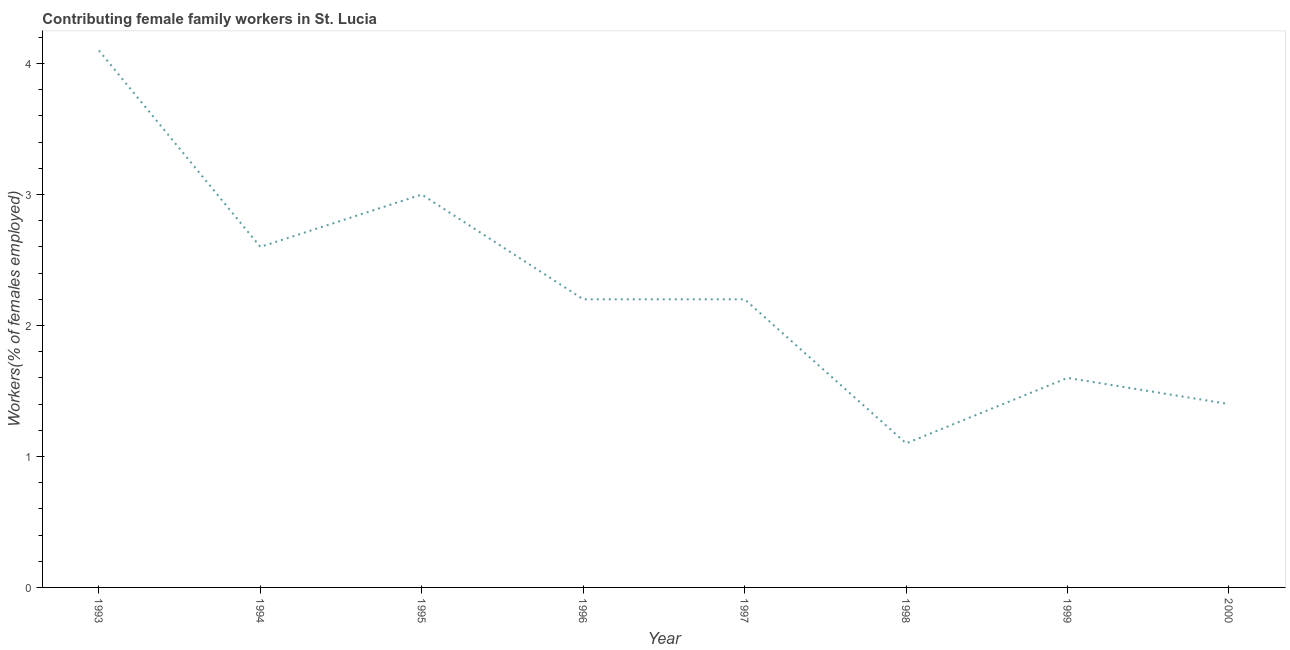Across all years, what is the maximum contributing female family workers?
Make the answer very short. 4.1. Across all years, what is the minimum contributing female family workers?
Your answer should be compact. 1.1. In which year was the contributing female family workers maximum?
Your answer should be very brief. 1993. In which year was the contributing female family workers minimum?
Provide a short and direct response. 1998. What is the sum of the contributing female family workers?
Offer a very short reply. 18.2. What is the difference between the contributing female family workers in 1998 and 2000?
Your answer should be compact. -0.3. What is the average contributing female family workers per year?
Your answer should be very brief. 2.27. What is the median contributing female family workers?
Your answer should be very brief. 2.2. Do a majority of the years between 1998 and 1993 (inclusive) have contributing female family workers greater than 0.2 %?
Ensure brevity in your answer.  Yes. What is the ratio of the contributing female family workers in 1993 to that in 2000?
Your answer should be compact. 2.93. What is the difference between the highest and the second highest contributing female family workers?
Offer a very short reply. 1.1. What is the difference between the highest and the lowest contributing female family workers?
Your answer should be very brief. 3. In how many years, is the contributing female family workers greater than the average contributing female family workers taken over all years?
Offer a very short reply. 3. Does the contributing female family workers monotonically increase over the years?
Ensure brevity in your answer.  No. How many lines are there?
Your answer should be compact. 1. What is the difference between two consecutive major ticks on the Y-axis?
Give a very brief answer. 1. Are the values on the major ticks of Y-axis written in scientific E-notation?
Your answer should be compact. No. Does the graph contain any zero values?
Offer a terse response. No. What is the title of the graph?
Ensure brevity in your answer.  Contributing female family workers in St. Lucia. What is the label or title of the X-axis?
Provide a succinct answer. Year. What is the label or title of the Y-axis?
Offer a terse response. Workers(% of females employed). What is the Workers(% of females employed) in 1993?
Make the answer very short. 4.1. What is the Workers(% of females employed) in 1994?
Offer a very short reply. 2.6. What is the Workers(% of females employed) in 1995?
Your response must be concise. 3. What is the Workers(% of females employed) of 1996?
Give a very brief answer. 2.2. What is the Workers(% of females employed) of 1997?
Offer a terse response. 2.2. What is the Workers(% of females employed) of 1998?
Your answer should be compact. 1.1. What is the Workers(% of females employed) in 1999?
Your answer should be very brief. 1.6. What is the Workers(% of females employed) of 2000?
Your response must be concise. 1.4. What is the difference between the Workers(% of females employed) in 1993 and 1994?
Your response must be concise. 1.5. What is the difference between the Workers(% of females employed) in 1993 and 1995?
Your response must be concise. 1.1. What is the difference between the Workers(% of females employed) in 1993 and 1999?
Provide a short and direct response. 2.5. What is the difference between the Workers(% of females employed) in 1993 and 2000?
Give a very brief answer. 2.7. What is the difference between the Workers(% of females employed) in 1994 and 1996?
Your answer should be compact. 0.4. What is the difference between the Workers(% of females employed) in 1994 and 1997?
Provide a short and direct response. 0.4. What is the difference between the Workers(% of females employed) in 1994 and 1998?
Provide a short and direct response. 1.5. What is the difference between the Workers(% of females employed) in 1994 and 2000?
Keep it short and to the point. 1.2. What is the difference between the Workers(% of females employed) in 1995 and 1996?
Ensure brevity in your answer.  0.8. What is the difference between the Workers(% of females employed) in 1995 and 1997?
Your response must be concise. 0.8. What is the difference between the Workers(% of females employed) in 1996 and 1998?
Offer a very short reply. 1.1. What is the difference between the Workers(% of females employed) in 1997 and 1998?
Your answer should be very brief. 1.1. What is the difference between the Workers(% of females employed) in 1997 and 1999?
Keep it short and to the point. 0.6. What is the difference between the Workers(% of females employed) in 1997 and 2000?
Give a very brief answer. 0.8. What is the difference between the Workers(% of females employed) in 1998 and 1999?
Your answer should be compact. -0.5. What is the ratio of the Workers(% of females employed) in 1993 to that in 1994?
Your answer should be compact. 1.58. What is the ratio of the Workers(% of females employed) in 1993 to that in 1995?
Your response must be concise. 1.37. What is the ratio of the Workers(% of females employed) in 1993 to that in 1996?
Your answer should be very brief. 1.86. What is the ratio of the Workers(% of females employed) in 1993 to that in 1997?
Give a very brief answer. 1.86. What is the ratio of the Workers(% of females employed) in 1993 to that in 1998?
Give a very brief answer. 3.73. What is the ratio of the Workers(% of females employed) in 1993 to that in 1999?
Give a very brief answer. 2.56. What is the ratio of the Workers(% of females employed) in 1993 to that in 2000?
Your response must be concise. 2.93. What is the ratio of the Workers(% of females employed) in 1994 to that in 1995?
Offer a very short reply. 0.87. What is the ratio of the Workers(% of females employed) in 1994 to that in 1996?
Offer a terse response. 1.18. What is the ratio of the Workers(% of females employed) in 1994 to that in 1997?
Make the answer very short. 1.18. What is the ratio of the Workers(% of females employed) in 1994 to that in 1998?
Ensure brevity in your answer.  2.36. What is the ratio of the Workers(% of females employed) in 1994 to that in 1999?
Provide a succinct answer. 1.62. What is the ratio of the Workers(% of females employed) in 1994 to that in 2000?
Your response must be concise. 1.86. What is the ratio of the Workers(% of females employed) in 1995 to that in 1996?
Your response must be concise. 1.36. What is the ratio of the Workers(% of females employed) in 1995 to that in 1997?
Keep it short and to the point. 1.36. What is the ratio of the Workers(% of females employed) in 1995 to that in 1998?
Give a very brief answer. 2.73. What is the ratio of the Workers(% of females employed) in 1995 to that in 1999?
Keep it short and to the point. 1.88. What is the ratio of the Workers(% of females employed) in 1995 to that in 2000?
Make the answer very short. 2.14. What is the ratio of the Workers(% of females employed) in 1996 to that in 1998?
Offer a very short reply. 2. What is the ratio of the Workers(% of females employed) in 1996 to that in 1999?
Provide a succinct answer. 1.38. What is the ratio of the Workers(% of females employed) in 1996 to that in 2000?
Your answer should be very brief. 1.57. What is the ratio of the Workers(% of females employed) in 1997 to that in 1999?
Give a very brief answer. 1.38. What is the ratio of the Workers(% of females employed) in 1997 to that in 2000?
Your answer should be very brief. 1.57. What is the ratio of the Workers(% of females employed) in 1998 to that in 1999?
Your response must be concise. 0.69. What is the ratio of the Workers(% of females employed) in 1998 to that in 2000?
Provide a succinct answer. 0.79. What is the ratio of the Workers(% of females employed) in 1999 to that in 2000?
Keep it short and to the point. 1.14. 